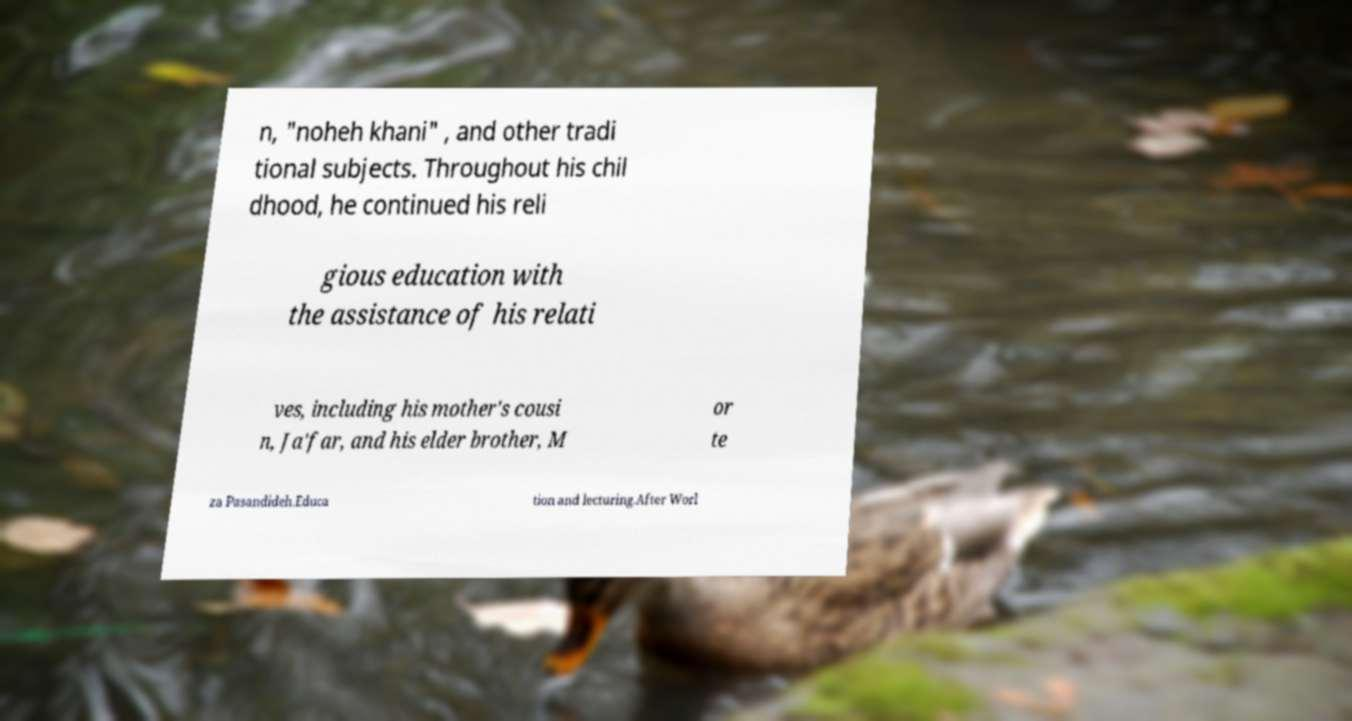I need the written content from this picture converted into text. Can you do that? n, "noheh khani" , and other tradi tional subjects. Throughout his chil dhood, he continued his reli gious education with the assistance of his relati ves, including his mother's cousi n, Ja'far, and his elder brother, M or te za Pasandideh.Educa tion and lecturing.After Worl 